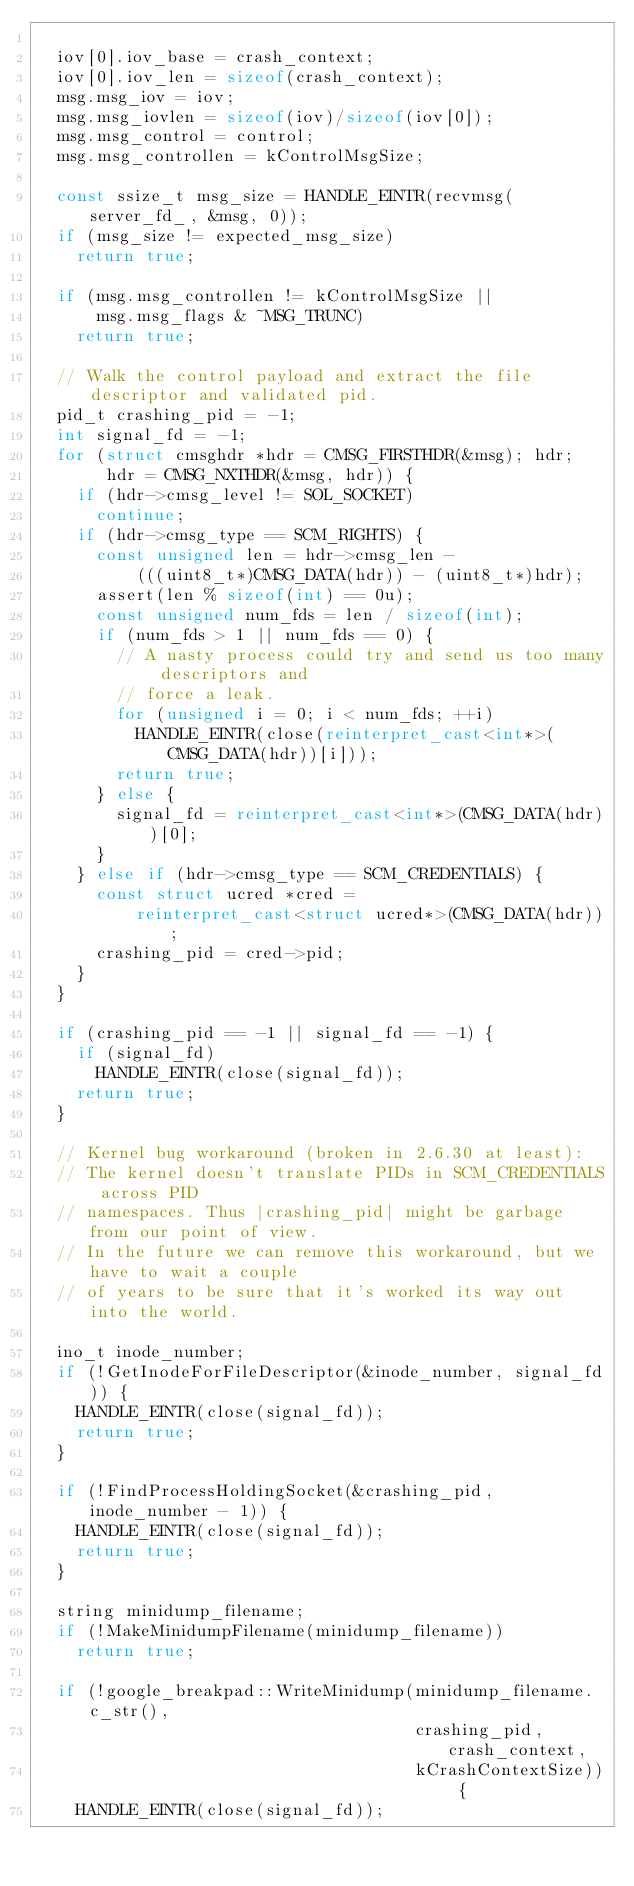Convert code to text. <code><loc_0><loc_0><loc_500><loc_500><_C++_>
  iov[0].iov_base = crash_context;
  iov[0].iov_len = sizeof(crash_context);
  msg.msg_iov = iov;
  msg.msg_iovlen = sizeof(iov)/sizeof(iov[0]);
  msg.msg_control = control;
  msg.msg_controllen = kControlMsgSize;

  const ssize_t msg_size = HANDLE_EINTR(recvmsg(server_fd_, &msg, 0));
  if (msg_size != expected_msg_size)
    return true;

  if (msg.msg_controllen != kControlMsgSize ||
      msg.msg_flags & ~MSG_TRUNC)
    return true;

  // Walk the control payload and extract the file descriptor and validated pid.
  pid_t crashing_pid = -1;
  int signal_fd = -1;
  for (struct cmsghdr *hdr = CMSG_FIRSTHDR(&msg); hdr;
       hdr = CMSG_NXTHDR(&msg, hdr)) {
    if (hdr->cmsg_level != SOL_SOCKET)
      continue;
    if (hdr->cmsg_type == SCM_RIGHTS) {
      const unsigned len = hdr->cmsg_len -
          (((uint8_t*)CMSG_DATA(hdr)) - (uint8_t*)hdr);
      assert(len % sizeof(int) == 0u);
      const unsigned num_fds = len / sizeof(int);
      if (num_fds > 1 || num_fds == 0) {
        // A nasty process could try and send us too many descriptors and
        // force a leak.
        for (unsigned i = 0; i < num_fds; ++i)
          HANDLE_EINTR(close(reinterpret_cast<int*>(CMSG_DATA(hdr))[i]));
        return true;
      } else {
        signal_fd = reinterpret_cast<int*>(CMSG_DATA(hdr))[0];
      }
    } else if (hdr->cmsg_type == SCM_CREDENTIALS) {
      const struct ucred *cred =
          reinterpret_cast<struct ucred*>(CMSG_DATA(hdr));
      crashing_pid = cred->pid;
    }
  }

  if (crashing_pid == -1 || signal_fd == -1) {
    if (signal_fd)
      HANDLE_EINTR(close(signal_fd));
    return true;
  }

  // Kernel bug workaround (broken in 2.6.30 at least):
  // The kernel doesn't translate PIDs in SCM_CREDENTIALS across PID
  // namespaces. Thus |crashing_pid| might be garbage from our point of view.
  // In the future we can remove this workaround, but we have to wait a couple
  // of years to be sure that it's worked its way out into the world.

  ino_t inode_number;
  if (!GetInodeForFileDescriptor(&inode_number, signal_fd)) {
    HANDLE_EINTR(close(signal_fd));
    return true;
  }

  if (!FindProcessHoldingSocket(&crashing_pid, inode_number - 1)) {
    HANDLE_EINTR(close(signal_fd));
    return true;
  }

  string minidump_filename;
  if (!MakeMinidumpFilename(minidump_filename))
    return true;

  if (!google_breakpad::WriteMinidump(minidump_filename.c_str(),
                                      crashing_pid, crash_context,
                                      kCrashContextSize)) {
    HANDLE_EINTR(close(signal_fd));</code> 